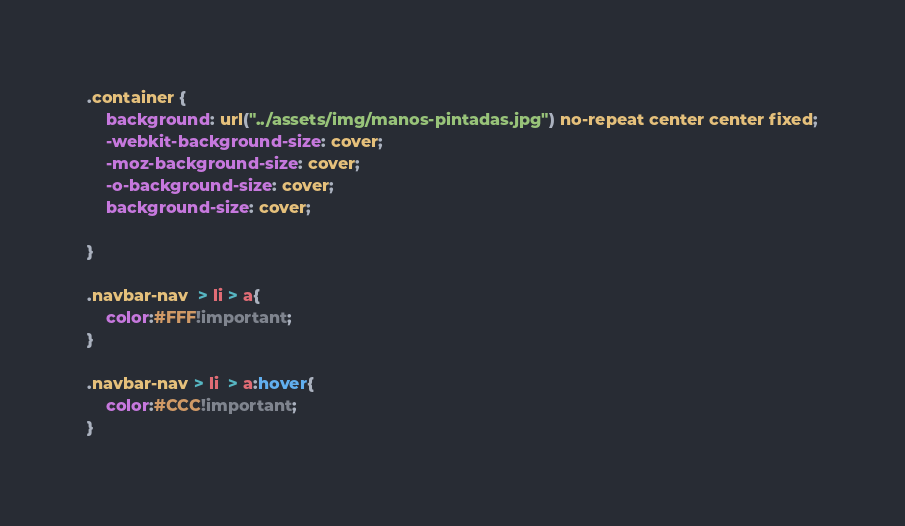Convert code to text. <code><loc_0><loc_0><loc_500><loc_500><_CSS_>.container {
	background: url("../assets/img/manos-pintadas.jpg") no-repeat center center fixed;
	-webkit-background-size: cover;
	-moz-background-size: cover;
	-o-background-size: cover;
	background-size: cover;
	
}

.navbar-nav  > li > a{
	color:#FFF!important;
}

.navbar-nav > li  > a:hover{
	color:#CCC!important;
}</code> 